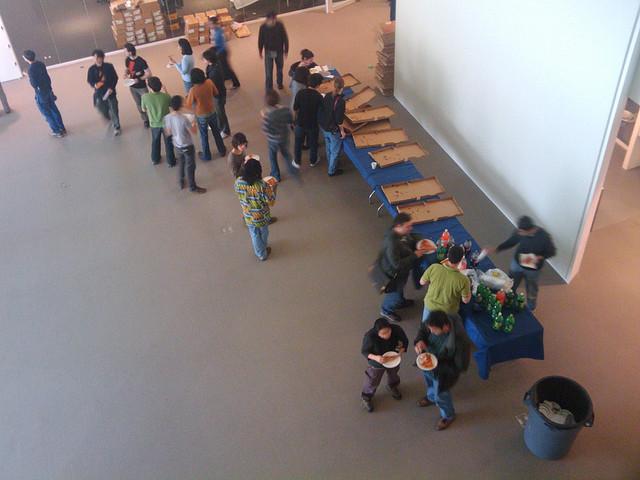What is on the plates?
Be succinct. Pizza. What color is the tablecloth?
Be succinct. Blue. Is the trash can empty?
Quick response, please. No. 